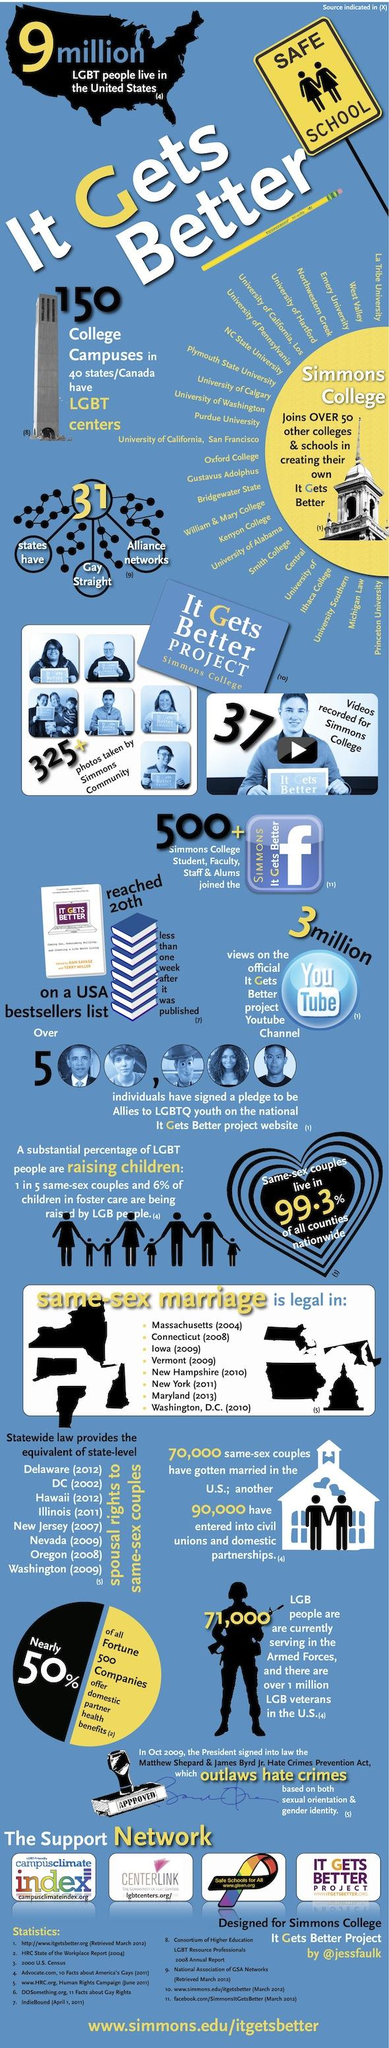Draw attention to some important aspects in this diagram. Same-sex marriage has been legal in the state of Iowa since 2009. There are 31 states that have alliance networks for gay and straight individuals. It is estimated that 500,000 individuals have signed the pledge on the website. The It Gets Better Project received 3 million YouTube views. In eight states, same-sex marriage is legal. 